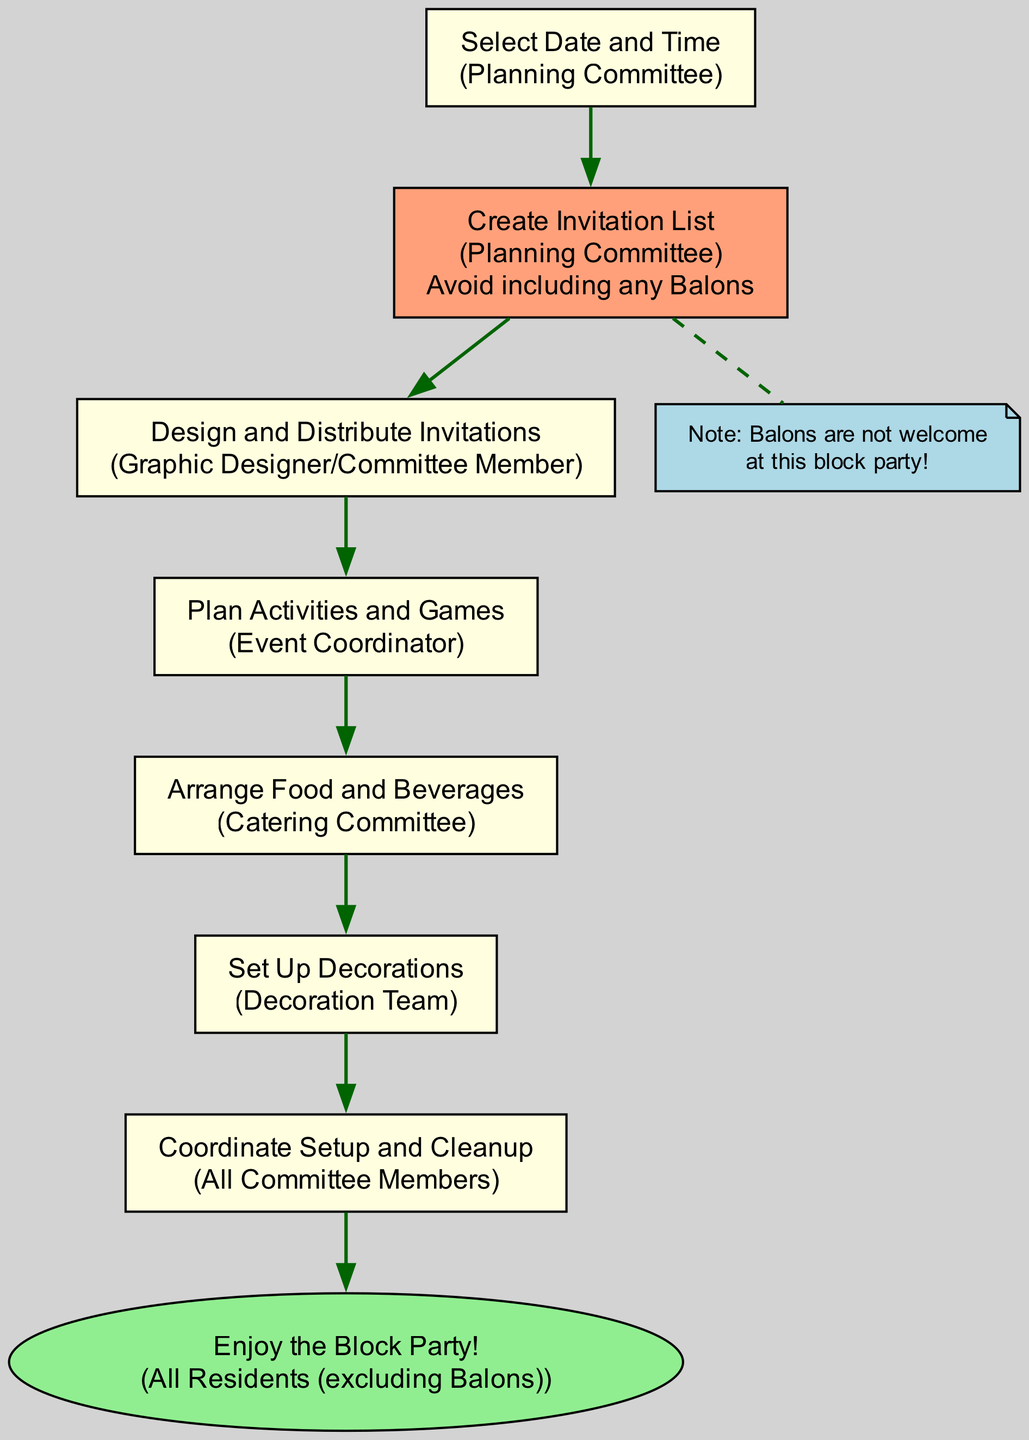What is the first task in the diagram? The first task in the diagram is "Select Date and Time," which can be found in the first node.
Answer: Select Date and Time Who is responsible for creating the invitation list? The responsibility for creating the invitation list lies with the Planning Committee, as stated in the second node of the diagram.
Answer: Planning Committee How many tasks are outlined in the flow chart? There are a total of eight tasks listed in the flow chart, from the first task to the last task of "Enjoy the Block Party!"
Answer: Eight Which task excludes the Balons? The task that explicitly mentions excluding the Balons is "Create Invitation List," as indicated in the second node that includes "Avoid including any Balons."
Answer: Create Invitation List What is the last task before enjoying the block party? The task just before enjoying the block party is "Coordinate Setup and Cleanup," which is the seventh task in the flow chart.
Answer: Coordinate Setup and Cleanup Which group is responsible for food arrangements? The Catering Committee is responsible for arranging food and beverages, as stated in the fifth node of the flow chart.
Answer: Catering Committee How is the "Enjoy the Block Party!" node represented in the diagram? The "Enjoy the Block Party!" node is represented as an oval shape and is colored light green according to the diagram characteristics for that task.
Answer: Oval shape What color indicates nodes that involve the exclusion of the Balons? Nodes that involve the exclusion of the Balons are colored lightsalmon, as can be seen in the node for "Create Invitation List."
Answer: Lightsalmon 